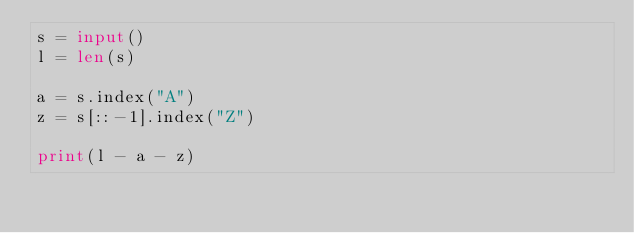<code> <loc_0><loc_0><loc_500><loc_500><_Python_>s = input()
l = len(s)

a = s.index("A")
z = s[::-1].index("Z")

print(l - a - z)</code> 